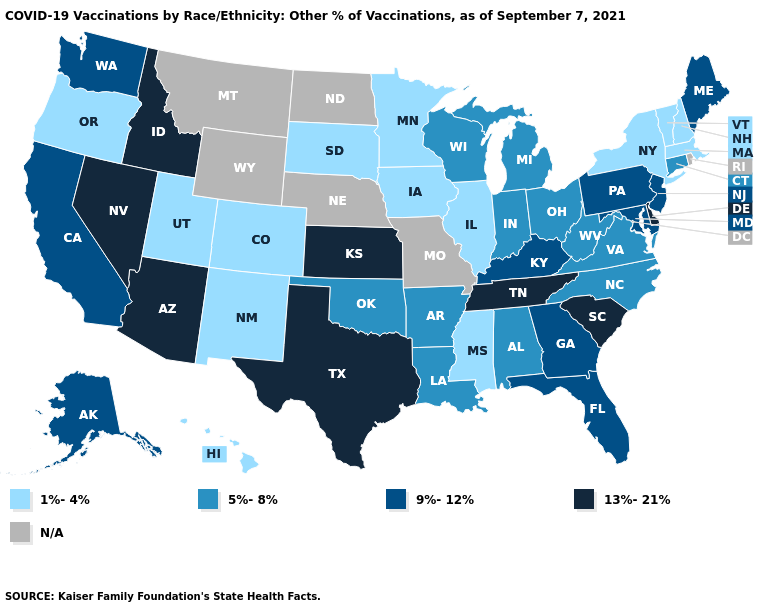What is the lowest value in the West?
Quick response, please. 1%-4%. Name the states that have a value in the range 9%-12%?
Write a very short answer. Alaska, California, Florida, Georgia, Kentucky, Maine, Maryland, New Jersey, Pennsylvania, Washington. Does Vermont have the lowest value in the USA?
Quick response, please. Yes. What is the lowest value in the USA?
Keep it brief. 1%-4%. Name the states that have a value in the range 1%-4%?
Quick response, please. Colorado, Hawaii, Illinois, Iowa, Massachusetts, Minnesota, Mississippi, New Hampshire, New Mexico, New York, Oregon, South Dakota, Utah, Vermont. Name the states that have a value in the range 1%-4%?
Be succinct. Colorado, Hawaii, Illinois, Iowa, Massachusetts, Minnesota, Mississippi, New Hampshire, New Mexico, New York, Oregon, South Dakota, Utah, Vermont. How many symbols are there in the legend?
Give a very brief answer. 5. Name the states that have a value in the range 9%-12%?
Give a very brief answer. Alaska, California, Florida, Georgia, Kentucky, Maine, Maryland, New Jersey, Pennsylvania, Washington. Among the states that border Nebraska , which have the highest value?
Be succinct. Kansas. Name the states that have a value in the range N/A?
Keep it brief. Missouri, Montana, Nebraska, North Dakota, Rhode Island, Wyoming. What is the value of Wyoming?
Write a very short answer. N/A. Name the states that have a value in the range 1%-4%?
Keep it brief. Colorado, Hawaii, Illinois, Iowa, Massachusetts, Minnesota, Mississippi, New Hampshire, New Mexico, New York, Oregon, South Dakota, Utah, Vermont. Name the states that have a value in the range N/A?
Short answer required. Missouri, Montana, Nebraska, North Dakota, Rhode Island, Wyoming. 